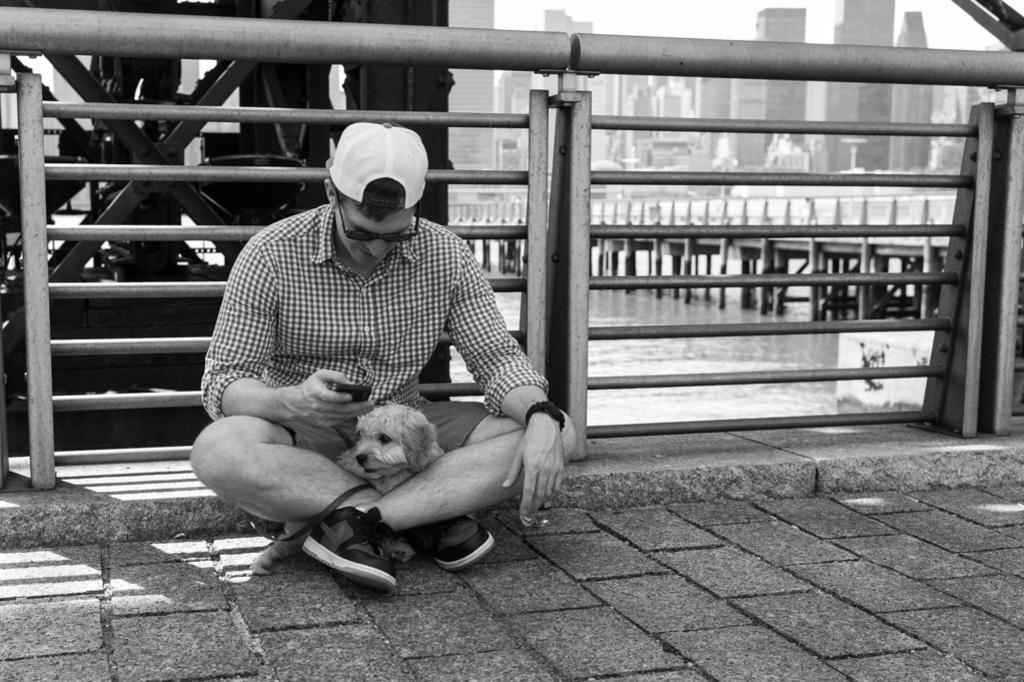What is the person in the image doing? The person is sitting on the road in the image. What animal is near the person? There is a dog near the person in the image. What is behind the person? There is fencing behind the person in the image. What can be seen in the water in the image? The provided facts do not mention anything specific about the water. What structures are visible in the background of the image? There is a bridge and buildings in the background of the image. Can you see any jellyfish swimming in the water in the image? There is no mention of jellyfish in the provided facts, and they are not visible in the image. What type of map is the person holding in the image? There is no map present in the image. 